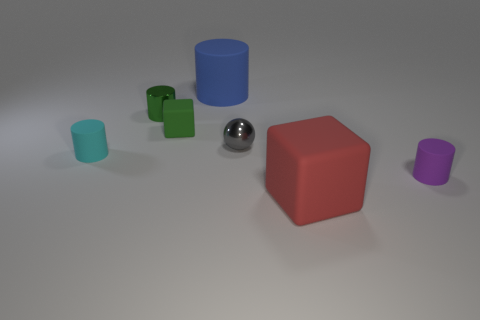Subtract 1 cylinders. How many cylinders are left? 3 Add 2 big red cubes. How many objects exist? 9 Subtract all cubes. How many objects are left? 5 Add 4 small objects. How many small objects exist? 9 Subtract 0 cyan blocks. How many objects are left? 7 Subtract all cylinders. Subtract all cyan rubber cylinders. How many objects are left? 2 Add 7 gray things. How many gray things are left? 8 